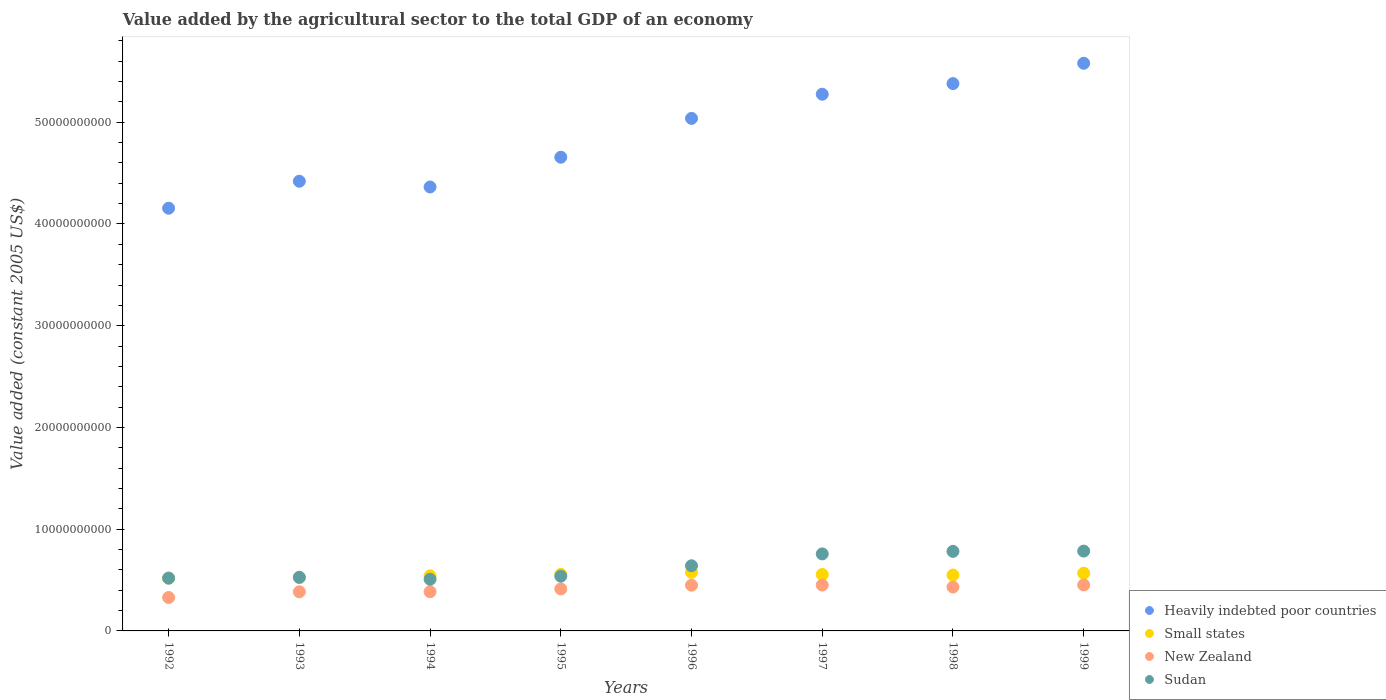Is the number of dotlines equal to the number of legend labels?
Offer a very short reply. Yes. What is the value added by the agricultural sector in Heavily indebted poor countries in 1994?
Offer a very short reply. 4.36e+1. Across all years, what is the maximum value added by the agricultural sector in New Zealand?
Your answer should be compact. 4.52e+09. Across all years, what is the minimum value added by the agricultural sector in Small states?
Offer a terse response. 5.19e+09. What is the total value added by the agricultural sector in Sudan in the graph?
Keep it short and to the point. 5.06e+1. What is the difference between the value added by the agricultural sector in Small states in 1997 and that in 1999?
Make the answer very short. -1.21e+08. What is the difference between the value added by the agricultural sector in Sudan in 1998 and the value added by the agricultural sector in New Zealand in 1992?
Provide a short and direct response. 4.54e+09. What is the average value added by the agricultural sector in Heavily indebted poor countries per year?
Give a very brief answer. 4.86e+1. In the year 1997, what is the difference between the value added by the agricultural sector in Small states and value added by the agricultural sector in Sudan?
Your answer should be very brief. -2.02e+09. What is the ratio of the value added by the agricultural sector in Small states in 1993 to that in 1995?
Your response must be concise. 0.94. Is the value added by the agricultural sector in Heavily indebted poor countries in 1996 less than that in 1998?
Make the answer very short. Yes. What is the difference between the highest and the second highest value added by the agricultural sector in New Zealand?
Your answer should be compact. 1.00e+07. What is the difference between the highest and the lowest value added by the agricultural sector in Sudan?
Make the answer very short. 2.77e+09. What is the difference between two consecutive major ticks on the Y-axis?
Make the answer very short. 1.00e+1. Does the graph contain any zero values?
Ensure brevity in your answer.  No. Where does the legend appear in the graph?
Your answer should be compact. Bottom right. How are the legend labels stacked?
Ensure brevity in your answer.  Vertical. What is the title of the graph?
Provide a succinct answer. Value added by the agricultural sector to the total GDP of an economy. What is the label or title of the X-axis?
Your answer should be very brief. Years. What is the label or title of the Y-axis?
Provide a succinct answer. Value added (constant 2005 US$). What is the Value added (constant 2005 US$) in Heavily indebted poor countries in 1992?
Provide a succinct answer. 4.15e+1. What is the Value added (constant 2005 US$) of Small states in 1992?
Your answer should be compact. 5.19e+09. What is the Value added (constant 2005 US$) in New Zealand in 1992?
Your answer should be compact. 3.28e+09. What is the Value added (constant 2005 US$) in Sudan in 1992?
Your answer should be compact. 5.19e+09. What is the Value added (constant 2005 US$) in Heavily indebted poor countries in 1993?
Give a very brief answer. 4.42e+1. What is the Value added (constant 2005 US$) of Small states in 1993?
Provide a short and direct response. 5.23e+09. What is the Value added (constant 2005 US$) of New Zealand in 1993?
Give a very brief answer. 3.84e+09. What is the Value added (constant 2005 US$) of Sudan in 1993?
Offer a terse response. 5.27e+09. What is the Value added (constant 2005 US$) of Heavily indebted poor countries in 1994?
Your response must be concise. 4.36e+1. What is the Value added (constant 2005 US$) in Small states in 1994?
Make the answer very short. 5.41e+09. What is the Value added (constant 2005 US$) in New Zealand in 1994?
Offer a terse response. 3.85e+09. What is the Value added (constant 2005 US$) in Sudan in 1994?
Offer a very short reply. 5.08e+09. What is the Value added (constant 2005 US$) in Heavily indebted poor countries in 1995?
Offer a very short reply. 4.66e+1. What is the Value added (constant 2005 US$) of Small states in 1995?
Offer a very short reply. 5.56e+09. What is the Value added (constant 2005 US$) of New Zealand in 1995?
Ensure brevity in your answer.  4.13e+09. What is the Value added (constant 2005 US$) in Sudan in 1995?
Offer a terse response. 5.38e+09. What is the Value added (constant 2005 US$) of Heavily indebted poor countries in 1996?
Offer a terse response. 5.04e+1. What is the Value added (constant 2005 US$) in Small states in 1996?
Your answer should be compact. 5.75e+09. What is the Value added (constant 2005 US$) in New Zealand in 1996?
Keep it short and to the point. 4.49e+09. What is the Value added (constant 2005 US$) in Sudan in 1996?
Your response must be concise. 6.40e+09. What is the Value added (constant 2005 US$) of Heavily indebted poor countries in 1997?
Provide a succinct answer. 5.28e+1. What is the Value added (constant 2005 US$) in Small states in 1997?
Keep it short and to the point. 5.55e+09. What is the Value added (constant 2005 US$) of New Zealand in 1997?
Provide a succinct answer. 4.51e+09. What is the Value added (constant 2005 US$) in Sudan in 1997?
Provide a succinct answer. 7.57e+09. What is the Value added (constant 2005 US$) of Heavily indebted poor countries in 1998?
Your answer should be compact. 5.38e+1. What is the Value added (constant 2005 US$) in Small states in 1998?
Your answer should be compact. 5.49e+09. What is the Value added (constant 2005 US$) in New Zealand in 1998?
Ensure brevity in your answer.  4.31e+09. What is the Value added (constant 2005 US$) in Sudan in 1998?
Your response must be concise. 7.82e+09. What is the Value added (constant 2005 US$) of Heavily indebted poor countries in 1999?
Your answer should be compact. 5.58e+1. What is the Value added (constant 2005 US$) of Small states in 1999?
Your answer should be very brief. 5.67e+09. What is the Value added (constant 2005 US$) in New Zealand in 1999?
Ensure brevity in your answer.  4.52e+09. What is the Value added (constant 2005 US$) in Sudan in 1999?
Your response must be concise. 7.85e+09. Across all years, what is the maximum Value added (constant 2005 US$) in Heavily indebted poor countries?
Provide a succinct answer. 5.58e+1. Across all years, what is the maximum Value added (constant 2005 US$) of Small states?
Ensure brevity in your answer.  5.75e+09. Across all years, what is the maximum Value added (constant 2005 US$) in New Zealand?
Your answer should be compact. 4.52e+09. Across all years, what is the maximum Value added (constant 2005 US$) in Sudan?
Offer a very short reply. 7.85e+09. Across all years, what is the minimum Value added (constant 2005 US$) in Heavily indebted poor countries?
Offer a very short reply. 4.15e+1. Across all years, what is the minimum Value added (constant 2005 US$) in Small states?
Your answer should be very brief. 5.19e+09. Across all years, what is the minimum Value added (constant 2005 US$) in New Zealand?
Your response must be concise. 3.28e+09. Across all years, what is the minimum Value added (constant 2005 US$) in Sudan?
Ensure brevity in your answer.  5.08e+09. What is the total Value added (constant 2005 US$) of Heavily indebted poor countries in the graph?
Provide a succinct answer. 3.89e+11. What is the total Value added (constant 2005 US$) in Small states in the graph?
Offer a terse response. 4.39e+1. What is the total Value added (constant 2005 US$) of New Zealand in the graph?
Provide a succinct answer. 3.29e+1. What is the total Value added (constant 2005 US$) of Sudan in the graph?
Offer a very short reply. 5.06e+1. What is the difference between the Value added (constant 2005 US$) in Heavily indebted poor countries in 1992 and that in 1993?
Offer a very short reply. -2.65e+09. What is the difference between the Value added (constant 2005 US$) in Small states in 1992 and that in 1993?
Your answer should be very brief. -3.83e+07. What is the difference between the Value added (constant 2005 US$) of New Zealand in 1992 and that in 1993?
Your response must be concise. -5.59e+08. What is the difference between the Value added (constant 2005 US$) in Sudan in 1992 and that in 1993?
Provide a succinct answer. -8.54e+07. What is the difference between the Value added (constant 2005 US$) of Heavily indebted poor countries in 1992 and that in 1994?
Provide a short and direct response. -2.09e+09. What is the difference between the Value added (constant 2005 US$) in Small states in 1992 and that in 1994?
Offer a terse response. -2.23e+08. What is the difference between the Value added (constant 2005 US$) of New Zealand in 1992 and that in 1994?
Ensure brevity in your answer.  -5.68e+08. What is the difference between the Value added (constant 2005 US$) in Sudan in 1992 and that in 1994?
Your response must be concise. 1.10e+08. What is the difference between the Value added (constant 2005 US$) of Heavily indebted poor countries in 1992 and that in 1995?
Your answer should be compact. -5.01e+09. What is the difference between the Value added (constant 2005 US$) in Small states in 1992 and that in 1995?
Your response must be concise. -3.70e+08. What is the difference between the Value added (constant 2005 US$) of New Zealand in 1992 and that in 1995?
Make the answer very short. -8.43e+08. What is the difference between the Value added (constant 2005 US$) of Sudan in 1992 and that in 1995?
Provide a short and direct response. -1.95e+08. What is the difference between the Value added (constant 2005 US$) in Heavily indebted poor countries in 1992 and that in 1996?
Offer a very short reply. -8.83e+09. What is the difference between the Value added (constant 2005 US$) in Small states in 1992 and that in 1996?
Provide a succinct answer. -5.63e+08. What is the difference between the Value added (constant 2005 US$) of New Zealand in 1992 and that in 1996?
Your response must be concise. -1.21e+09. What is the difference between the Value added (constant 2005 US$) in Sudan in 1992 and that in 1996?
Your answer should be compact. -1.22e+09. What is the difference between the Value added (constant 2005 US$) of Heavily indebted poor countries in 1992 and that in 1997?
Ensure brevity in your answer.  -1.12e+1. What is the difference between the Value added (constant 2005 US$) of Small states in 1992 and that in 1997?
Offer a very short reply. -3.58e+08. What is the difference between the Value added (constant 2005 US$) of New Zealand in 1992 and that in 1997?
Offer a very short reply. -1.22e+09. What is the difference between the Value added (constant 2005 US$) in Sudan in 1992 and that in 1997?
Give a very brief answer. -2.38e+09. What is the difference between the Value added (constant 2005 US$) of Heavily indebted poor countries in 1992 and that in 1998?
Offer a very short reply. -1.22e+1. What is the difference between the Value added (constant 2005 US$) in Small states in 1992 and that in 1998?
Ensure brevity in your answer.  -3.03e+08. What is the difference between the Value added (constant 2005 US$) in New Zealand in 1992 and that in 1998?
Offer a very short reply. -1.03e+09. What is the difference between the Value added (constant 2005 US$) of Sudan in 1992 and that in 1998?
Provide a succinct answer. -2.63e+09. What is the difference between the Value added (constant 2005 US$) of Heavily indebted poor countries in 1992 and that in 1999?
Offer a very short reply. -1.42e+1. What is the difference between the Value added (constant 2005 US$) in Small states in 1992 and that in 1999?
Provide a succinct answer. -4.79e+08. What is the difference between the Value added (constant 2005 US$) of New Zealand in 1992 and that in 1999?
Provide a succinct answer. -1.23e+09. What is the difference between the Value added (constant 2005 US$) of Sudan in 1992 and that in 1999?
Your answer should be compact. -2.66e+09. What is the difference between the Value added (constant 2005 US$) in Heavily indebted poor countries in 1993 and that in 1994?
Offer a terse response. 5.63e+08. What is the difference between the Value added (constant 2005 US$) in Small states in 1993 and that in 1994?
Ensure brevity in your answer.  -1.85e+08. What is the difference between the Value added (constant 2005 US$) of New Zealand in 1993 and that in 1994?
Ensure brevity in your answer.  -8.66e+06. What is the difference between the Value added (constant 2005 US$) of Sudan in 1993 and that in 1994?
Offer a terse response. 1.95e+08. What is the difference between the Value added (constant 2005 US$) of Heavily indebted poor countries in 1993 and that in 1995?
Your response must be concise. -2.36e+09. What is the difference between the Value added (constant 2005 US$) in Small states in 1993 and that in 1995?
Give a very brief answer. -3.31e+08. What is the difference between the Value added (constant 2005 US$) in New Zealand in 1993 and that in 1995?
Ensure brevity in your answer.  -2.84e+08. What is the difference between the Value added (constant 2005 US$) of Sudan in 1993 and that in 1995?
Provide a succinct answer. -1.09e+08. What is the difference between the Value added (constant 2005 US$) of Heavily indebted poor countries in 1993 and that in 1996?
Ensure brevity in your answer.  -6.18e+09. What is the difference between the Value added (constant 2005 US$) of Small states in 1993 and that in 1996?
Your answer should be very brief. -5.25e+08. What is the difference between the Value added (constant 2005 US$) of New Zealand in 1993 and that in 1996?
Your answer should be compact. -6.48e+08. What is the difference between the Value added (constant 2005 US$) of Sudan in 1993 and that in 1996?
Make the answer very short. -1.13e+09. What is the difference between the Value added (constant 2005 US$) of Heavily indebted poor countries in 1993 and that in 1997?
Offer a very short reply. -8.55e+09. What is the difference between the Value added (constant 2005 US$) of Small states in 1993 and that in 1997?
Your answer should be compact. -3.19e+08. What is the difference between the Value added (constant 2005 US$) in New Zealand in 1993 and that in 1997?
Keep it short and to the point. -6.66e+08. What is the difference between the Value added (constant 2005 US$) in Sudan in 1993 and that in 1997?
Your answer should be very brief. -2.30e+09. What is the difference between the Value added (constant 2005 US$) in Heavily indebted poor countries in 1993 and that in 1998?
Give a very brief answer. -9.60e+09. What is the difference between the Value added (constant 2005 US$) in Small states in 1993 and that in 1998?
Offer a very short reply. -2.65e+08. What is the difference between the Value added (constant 2005 US$) of New Zealand in 1993 and that in 1998?
Offer a very short reply. -4.70e+08. What is the difference between the Value added (constant 2005 US$) in Sudan in 1993 and that in 1998?
Your answer should be very brief. -2.55e+09. What is the difference between the Value added (constant 2005 US$) of Heavily indebted poor countries in 1993 and that in 1999?
Keep it short and to the point. -1.16e+1. What is the difference between the Value added (constant 2005 US$) of Small states in 1993 and that in 1999?
Provide a short and direct response. -4.41e+08. What is the difference between the Value added (constant 2005 US$) of New Zealand in 1993 and that in 1999?
Keep it short and to the point. -6.76e+08. What is the difference between the Value added (constant 2005 US$) in Sudan in 1993 and that in 1999?
Offer a terse response. -2.57e+09. What is the difference between the Value added (constant 2005 US$) in Heavily indebted poor countries in 1994 and that in 1995?
Provide a short and direct response. -2.92e+09. What is the difference between the Value added (constant 2005 US$) in Small states in 1994 and that in 1995?
Keep it short and to the point. -1.46e+08. What is the difference between the Value added (constant 2005 US$) of New Zealand in 1994 and that in 1995?
Your answer should be very brief. -2.75e+08. What is the difference between the Value added (constant 2005 US$) of Sudan in 1994 and that in 1995?
Give a very brief answer. -3.05e+08. What is the difference between the Value added (constant 2005 US$) of Heavily indebted poor countries in 1994 and that in 1996?
Offer a terse response. -6.74e+09. What is the difference between the Value added (constant 2005 US$) of Small states in 1994 and that in 1996?
Offer a very short reply. -3.40e+08. What is the difference between the Value added (constant 2005 US$) in New Zealand in 1994 and that in 1996?
Your answer should be very brief. -6.40e+08. What is the difference between the Value added (constant 2005 US$) in Sudan in 1994 and that in 1996?
Provide a succinct answer. -1.33e+09. What is the difference between the Value added (constant 2005 US$) in Heavily indebted poor countries in 1994 and that in 1997?
Offer a terse response. -9.12e+09. What is the difference between the Value added (constant 2005 US$) of Small states in 1994 and that in 1997?
Ensure brevity in your answer.  -1.34e+08. What is the difference between the Value added (constant 2005 US$) of New Zealand in 1994 and that in 1997?
Your response must be concise. -6.57e+08. What is the difference between the Value added (constant 2005 US$) in Sudan in 1994 and that in 1997?
Provide a short and direct response. -2.49e+09. What is the difference between the Value added (constant 2005 US$) of Heavily indebted poor countries in 1994 and that in 1998?
Your response must be concise. -1.02e+1. What is the difference between the Value added (constant 2005 US$) of Small states in 1994 and that in 1998?
Offer a terse response. -8.01e+07. What is the difference between the Value added (constant 2005 US$) in New Zealand in 1994 and that in 1998?
Your answer should be very brief. -4.61e+08. What is the difference between the Value added (constant 2005 US$) of Sudan in 1994 and that in 1998?
Your answer should be compact. -2.74e+09. What is the difference between the Value added (constant 2005 US$) of Heavily indebted poor countries in 1994 and that in 1999?
Give a very brief answer. -1.22e+1. What is the difference between the Value added (constant 2005 US$) in Small states in 1994 and that in 1999?
Your answer should be very brief. -2.56e+08. What is the difference between the Value added (constant 2005 US$) in New Zealand in 1994 and that in 1999?
Offer a very short reply. -6.67e+08. What is the difference between the Value added (constant 2005 US$) of Sudan in 1994 and that in 1999?
Offer a very short reply. -2.77e+09. What is the difference between the Value added (constant 2005 US$) in Heavily indebted poor countries in 1995 and that in 1996?
Offer a very short reply. -3.82e+09. What is the difference between the Value added (constant 2005 US$) of Small states in 1995 and that in 1996?
Give a very brief answer. -1.94e+08. What is the difference between the Value added (constant 2005 US$) of New Zealand in 1995 and that in 1996?
Give a very brief answer. -3.64e+08. What is the difference between the Value added (constant 2005 US$) of Sudan in 1995 and that in 1996?
Offer a terse response. -1.02e+09. What is the difference between the Value added (constant 2005 US$) in Heavily indebted poor countries in 1995 and that in 1997?
Ensure brevity in your answer.  -6.19e+09. What is the difference between the Value added (constant 2005 US$) in Small states in 1995 and that in 1997?
Keep it short and to the point. 1.20e+07. What is the difference between the Value added (constant 2005 US$) of New Zealand in 1995 and that in 1997?
Ensure brevity in your answer.  -3.82e+08. What is the difference between the Value added (constant 2005 US$) of Sudan in 1995 and that in 1997?
Your answer should be very brief. -2.19e+09. What is the difference between the Value added (constant 2005 US$) of Heavily indebted poor countries in 1995 and that in 1998?
Provide a succinct answer. -7.24e+09. What is the difference between the Value added (constant 2005 US$) in Small states in 1995 and that in 1998?
Make the answer very short. 6.63e+07. What is the difference between the Value added (constant 2005 US$) in New Zealand in 1995 and that in 1998?
Provide a short and direct response. -1.86e+08. What is the difference between the Value added (constant 2005 US$) in Sudan in 1995 and that in 1998?
Give a very brief answer. -2.44e+09. What is the difference between the Value added (constant 2005 US$) in Heavily indebted poor countries in 1995 and that in 1999?
Your answer should be compact. -9.23e+09. What is the difference between the Value added (constant 2005 US$) of Small states in 1995 and that in 1999?
Give a very brief answer. -1.09e+08. What is the difference between the Value added (constant 2005 US$) in New Zealand in 1995 and that in 1999?
Your response must be concise. -3.92e+08. What is the difference between the Value added (constant 2005 US$) in Sudan in 1995 and that in 1999?
Provide a succinct answer. -2.46e+09. What is the difference between the Value added (constant 2005 US$) of Heavily indebted poor countries in 1996 and that in 1997?
Provide a succinct answer. -2.37e+09. What is the difference between the Value added (constant 2005 US$) of Small states in 1996 and that in 1997?
Your answer should be very brief. 2.05e+08. What is the difference between the Value added (constant 2005 US$) in New Zealand in 1996 and that in 1997?
Provide a short and direct response. -1.73e+07. What is the difference between the Value added (constant 2005 US$) in Sudan in 1996 and that in 1997?
Ensure brevity in your answer.  -1.17e+09. What is the difference between the Value added (constant 2005 US$) in Heavily indebted poor countries in 1996 and that in 1998?
Provide a short and direct response. -3.42e+09. What is the difference between the Value added (constant 2005 US$) of Small states in 1996 and that in 1998?
Provide a short and direct response. 2.60e+08. What is the difference between the Value added (constant 2005 US$) of New Zealand in 1996 and that in 1998?
Offer a terse response. 1.79e+08. What is the difference between the Value added (constant 2005 US$) of Sudan in 1996 and that in 1998?
Offer a very short reply. -1.42e+09. What is the difference between the Value added (constant 2005 US$) in Heavily indebted poor countries in 1996 and that in 1999?
Your answer should be very brief. -5.42e+09. What is the difference between the Value added (constant 2005 US$) in Small states in 1996 and that in 1999?
Your answer should be compact. 8.41e+07. What is the difference between the Value added (constant 2005 US$) of New Zealand in 1996 and that in 1999?
Keep it short and to the point. -2.74e+07. What is the difference between the Value added (constant 2005 US$) in Sudan in 1996 and that in 1999?
Provide a short and direct response. -1.44e+09. What is the difference between the Value added (constant 2005 US$) of Heavily indebted poor countries in 1997 and that in 1998?
Offer a terse response. -1.04e+09. What is the difference between the Value added (constant 2005 US$) of Small states in 1997 and that in 1998?
Keep it short and to the point. 5.43e+07. What is the difference between the Value added (constant 2005 US$) of New Zealand in 1997 and that in 1998?
Your answer should be compact. 1.96e+08. What is the difference between the Value added (constant 2005 US$) of Sudan in 1997 and that in 1998?
Give a very brief answer. -2.50e+08. What is the difference between the Value added (constant 2005 US$) of Heavily indebted poor countries in 1997 and that in 1999?
Ensure brevity in your answer.  -3.04e+09. What is the difference between the Value added (constant 2005 US$) in Small states in 1997 and that in 1999?
Your answer should be compact. -1.21e+08. What is the difference between the Value added (constant 2005 US$) in New Zealand in 1997 and that in 1999?
Ensure brevity in your answer.  -1.00e+07. What is the difference between the Value added (constant 2005 US$) in Sudan in 1997 and that in 1999?
Ensure brevity in your answer.  -2.76e+08. What is the difference between the Value added (constant 2005 US$) in Heavily indebted poor countries in 1998 and that in 1999?
Your answer should be very brief. -2.00e+09. What is the difference between the Value added (constant 2005 US$) in Small states in 1998 and that in 1999?
Provide a succinct answer. -1.76e+08. What is the difference between the Value added (constant 2005 US$) of New Zealand in 1998 and that in 1999?
Your answer should be compact. -2.06e+08. What is the difference between the Value added (constant 2005 US$) in Sudan in 1998 and that in 1999?
Your response must be concise. -2.61e+07. What is the difference between the Value added (constant 2005 US$) of Heavily indebted poor countries in 1992 and the Value added (constant 2005 US$) of Small states in 1993?
Give a very brief answer. 3.63e+1. What is the difference between the Value added (constant 2005 US$) of Heavily indebted poor countries in 1992 and the Value added (constant 2005 US$) of New Zealand in 1993?
Your answer should be compact. 3.77e+1. What is the difference between the Value added (constant 2005 US$) of Heavily indebted poor countries in 1992 and the Value added (constant 2005 US$) of Sudan in 1993?
Provide a short and direct response. 3.63e+1. What is the difference between the Value added (constant 2005 US$) in Small states in 1992 and the Value added (constant 2005 US$) in New Zealand in 1993?
Your answer should be compact. 1.35e+09. What is the difference between the Value added (constant 2005 US$) of Small states in 1992 and the Value added (constant 2005 US$) of Sudan in 1993?
Offer a terse response. -8.18e+07. What is the difference between the Value added (constant 2005 US$) of New Zealand in 1992 and the Value added (constant 2005 US$) of Sudan in 1993?
Keep it short and to the point. -1.99e+09. What is the difference between the Value added (constant 2005 US$) of Heavily indebted poor countries in 1992 and the Value added (constant 2005 US$) of Small states in 1994?
Your answer should be compact. 3.61e+1. What is the difference between the Value added (constant 2005 US$) in Heavily indebted poor countries in 1992 and the Value added (constant 2005 US$) in New Zealand in 1994?
Your response must be concise. 3.77e+1. What is the difference between the Value added (constant 2005 US$) of Heavily indebted poor countries in 1992 and the Value added (constant 2005 US$) of Sudan in 1994?
Provide a short and direct response. 3.65e+1. What is the difference between the Value added (constant 2005 US$) in Small states in 1992 and the Value added (constant 2005 US$) in New Zealand in 1994?
Your answer should be very brief. 1.34e+09. What is the difference between the Value added (constant 2005 US$) in Small states in 1992 and the Value added (constant 2005 US$) in Sudan in 1994?
Provide a succinct answer. 1.14e+08. What is the difference between the Value added (constant 2005 US$) of New Zealand in 1992 and the Value added (constant 2005 US$) of Sudan in 1994?
Keep it short and to the point. -1.79e+09. What is the difference between the Value added (constant 2005 US$) in Heavily indebted poor countries in 1992 and the Value added (constant 2005 US$) in Small states in 1995?
Your answer should be compact. 3.60e+1. What is the difference between the Value added (constant 2005 US$) of Heavily indebted poor countries in 1992 and the Value added (constant 2005 US$) of New Zealand in 1995?
Provide a succinct answer. 3.74e+1. What is the difference between the Value added (constant 2005 US$) of Heavily indebted poor countries in 1992 and the Value added (constant 2005 US$) of Sudan in 1995?
Ensure brevity in your answer.  3.62e+1. What is the difference between the Value added (constant 2005 US$) of Small states in 1992 and the Value added (constant 2005 US$) of New Zealand in 1995?
Make the answer very short. 1.06e+09. What is the difference between the Value added (constant 2005 US$) in Small states in 1992 and the Value added (constant 2005 US$) in Sudan in 1995?
Provide a succinct answer. -1.91e+08. What is the difference between the Value added (constant 2005 US$) of New Zealand in 1992 and the Value added (constant 2005 US$) of Sudan in 1995?
Your response must be concise. -2.10e+09. What is the difference between the Value added (constant 2005 US$) in Heavily indebted poor countries in 1992 and the Value added (constant 2005 US$) in Small states in 1996?
Make the answer very short. 3.58e+1. What is the difference between the Value added (constant 2005 US$) in Heavily indebted poor countries in 1992 and the Value added (constant 2005 US$) in New Zealand in 1996?
Ensure brevity in your answer.  3.71e+1. What is the difference between the Value added (constant 2005 US$) in Heavily indebted poor countries in 1992 and the Value added (constant 2005 US$) in Sudan in 1996?
Ensure brevity in your answer.  3.51e+1. What is the difference between the Value added (constant 2005 US$) of Small states in 1992 and the Value added (constant 2005 US$) of New Zealand in 1996?
Provide a succinct answer. 6.98e+08. What is the difference between the Value added (constant 2005 US$) of Small states in 1992 and the Value added (constant 2005 US$) of Sudan in 1996?
Offer a terse response. -1.21e+09. What is the difference between the Value added (constant 2005 US$) of New Zealand in 1992 and the Value added (constant 2005 US$) of Sudan in 1996?
Keep it short and to the point. -3.12e+09. What is the difference between the Value added (constant 2005 US$) of Heavily indebted poor countries in 1992 and the Value added (constant 2005 US$) of Small states in 1997?
Keep it short and to the point. 3.60e+1. What is the difference between the Value added (constant 2005 US$) of Heavily indebted poor countries in 1992 and the Value added (constant 2005 US$) of New Zealand in 1997?
Offer a very short reply. 3.70e+1. What is the difference between the Value added (constant 2005 US$) in Heavily indebted poor countries in 1992 and the Value added (constant 2005 US$) in Sudan in 1997?
Your answer should be compact. 3.40e+1. What is the difference between the Value added (constant 2005 US$) of Small states in 1992 and the Value added (constant 2005 US$) of New Zealand in 1997?
Your response must be concise. 6.81e+08. What is the difference between the Value added (constant 2005 US$) in Small states in 1992 and the Value added (constant 2005 US$) in Sudan in 1997?
Your response must be concise. -2.38e+09. What is the difference between the Value added (constant 2005 US$) in New Zealand in 1992 and the Value added (constant 2005 US$) in Sudan in 1997?
Provide a succinct answer. -4.29e+09. What is the difference between the Value added (constant 2005 US$) of Heavily indebted poor countries in 1992 and the Value added (constant 2005 US$) of Small states in 1998?
Provide a short and direct response. 3.61e+1. What is the difference between the Value added (constant 2005 US$) in Heavily indebted poor countries in 1992 and the Value added (constant 2005 US$) in New Zealand in 1998?
Keep it short and to the point. 3.72e+1. What is the difference between the Value added (constant 2005 US$) of Heavily indebted poor countries in 1992 and the Value added (constant 2005 US$) of Sudan in 1998?
Provide a succinct answer. 3.37e+1. What is the difference between the Value added (constant 2005 US$) of Small states in 1992 and the Value added (constant 2005 US$) of New Zealand in 1998?
Your response must be concise. 8.77e+08. What is the difference between the Value added (constant 2005 US$) in Small states in 1992 and the Value added (constant 2005 US$) in Sudan in 1998?
Offer a very short reply. -2.63e+09. What is the difference between the Value added (constant 2005 US$) of New Zealand in 1992 and the Value added (constant 2005 US$) of Sudan in 1998?
Provide a succinct answer. -4.54e+09. What is the difference between the Value added (constant 2005 US$) in Heavily indebted poor countries in 1992 and the Value added (constant 2005 US$) in Small states in 1999?
Offer a very short reply. 3.59e+1. What is the difference between the Value added (constant 2005 US$) in Heavily indebted poor countries in 1992 and the Value added (constant 2005 US$) in New Zealand in 1999?
Your answer should be very brief. 3.70e+1. What is the difference between the Value added (constant 2005 US$) in Heavily indebted poor countries in 1992 and the Value added (constant 2005 US$) in Sudan in 1999?
Offer a terse response. 3.37e+1. What is the difference between the Value added (constant 2005 US$) in Small states in 1992 and the Value added (constant 2005 US$) in New Zealand in 1999?
Make the answer very short. 6.71e+08. What is the difference between the Value added (constant 2005 US$) in Small states in 1992 and the Value added (constant 2005 US$) in Sudan in 1999?
Make the answer very short. -2.66e+09. What is the difference between the Value added (constant 2005 US$) of New Zealand in 1992 and the Value added (constant 2005 US$) of Sudan in 1999?
Make the answer very short. -4.56e+09. What is the difference between the Value added (constant 2005 US$) in Heavily indebted poor countries in 1993 and the Value added (constant 2005 US$) in Small states in 1994?
Your answer should be compact. 3.88e+1. What is the difference between the Value added (constant 2005 US$) in Heavily indebted poor countries in 1993 and the Value added (constant 2005 US$) in New Zealand in 1994?
Keep it short and to the point. 4.03e+1. What is the difference between the Value added (constant 2005 US$) of Heavily indebted poor countries in 1993 and the Value added (constant 2005 US$) of Sudan in 1994?
Offer a very short reply. 3.91e+1. What is the difference between the Value added (constant 2005 US$) in Small states in 1993 and the Value added (constant 2005 US$) in New Zealand in 1994?
Provide a succinct answer. 1.38e+09. What is the difference between the Value added (constant 2005 US$) in Small states in 1993 and the Value added (constant 2005 US$) in Sudan in 1994?
Your answer should be compact. 1.52e+08. What is the difference between the Value added (constant 2005 US$) of New Zealand in 1993 and the Value added (constant 2005 US$) of Sudan in 1994?
Keep it short and to the point. -1.23e+09. What is the difference between the Value added (constant 2005 US$) of Heavily indebted poor countries in 1993 and the Value added (constant 2005 US$) of Small states in 1995?
Make the answer very short. 3.86e+1. What is the difference between the Value added (constant 2005 US$) of Heavily indebted poor countries in 1993 and the Value added (constant 2005 US$) of New Zealand in 1995?
Your answer should be very brief. 4.01e+1. What is the difference between the Value added (constant 2005 US$) in Heavily indebted poor countries in 1993 and the Value added (constant 2005 US$) in Sudan in 1995?
Your answer should be compact. 3.88e+1. What is the difference between the Value added (constant 2005 US$) of Small states in 1993 and the Value added (constant 2005 US$) of New Zealand in 1995?
Keep it short and to the point. 1.10e+09. What is the difference between the Value added (constant 2005 US$) of Small states in 1993 and the Value added (constant 2005 US$) of Sudan in 1995?
Make the answer very short. -1.53e+08. What is the difference between the Value added (constant 2005 US$) of New Zealand in 1993 and the Value added (constant 2005 US$) of Sudan in 1995?
Keep it short and to the point. -1.54e+09. What is the difference between the Value added (constant 2005 US$) in Heavily indebted poor countries in 1993 and the Value added (constant 2005 US$) in Small states in 1996?
Provide a short and direct response. 3.84e+1. What is the difference between the Value added (constant 2005 US$) of Heavily indebted poor countries in 1993 and the Value added (constant 2005 US$) of New Zealand in 1996?
Your answer should be very brief. 3.97e+1. What is the difference between the Value added (constant 2005 US$) of Heavily indebted poor countries in 1993 and the Value added (constant 2005 US$) of Sudan in 1996?
Your answer should be very brief. 3.78e+1. What is the difference between the Value added (constant 2005 US$) of Small states in 1993 and the Value added (constant 2005 US$) of New Zealand in 1996?
Offer a very short reply. 7.37e+08. What is the difference between the Value added (constant 2005 US$) in Small states in 1993 and the Value added (constant 2005 US$) in Sudan in 1996?
Offer a very short reply. -1.17e+09. What is the difference between the Value added (constant 2005 US$) of New Zealand in 1993 and the Value added (constant 2005 US$) of Sudan in 1996?
Offer a very short reply. -2.56e+09. What is the difference between the Value added (constant 2005 US$) of Heavily indebted poor countries in 1993 and the Value added (constant 2005 US$) of Small states in 1997?
Provide a short and direct response. 3.87e+1. What is the difference between the Value added (constant 2005 US$) of Heavily indebted poor countries in 1993 and the Value added (constant 2005 US$) of New Zealand in 1997?
Keep it short and to the point. 3.97e+1. What is the difference between the Value added (constant 2005 US$) of Heavily indebted poor countries in 1993 and the Value added (constant 2005 US$) of Sudan in 1997?
Ensure brevity in your answer.  3.66e+1. What is the difference between the Value added (constant 2005 US$) of Small states in 1993 and the Value added (constant 2005 US$) of New Zealand in 1997?
Give a very brief answer. 7.19e+08. What is the difference between the Value added (constant 2005 US$) of Small states in 1993 and the Value added (constant 2005 US$) of Sudan in 1997?
Your response must be concise. -2.34e+09. What is the difference between the Value added (constant 2005 US$) of New Zealand in 1993 and the Value added (constant 2005 US$) of Sudan in 1997?
Offer a terse response. -3.73e+09. What is the difference between the Value added (constant 2005 US$) of Heavily indebted poor countries in 1993 and the Value added (constant 2005 US$) of Small states in 1998?
Make the answer very short. 3.87e+1. What is the difference between the Value added (constant 2005 US$) of Heavily indebted poor countries in 1993 and the Value added (constant 2005 US$) of New Zealand in 1998?
Offer a very short reply. 3.99e+1. What is the difference between the Value added (constant 2005 US$) in Heavily indebted poor countries in 1993 and the Value added (constant 2005 US$) in Sudan in 1998?
Keep it short and to the point. 3.64e+1. What is the difference between the Value added (constant 2005 US$) in Small states in 1993 and the Value added (constant 2005 US$) in New Zealand in 1998?
Make the answer very short. 9.16e+08. What is the difference between the Value added (constant 2005 US$) of Small states in 1993 and the Value added (constant 2005 US$) of Sudan in 1998?
Give a very brief answer. -2.59e+09. What is the difference between the Value added (constant 2005 US$) in New Zealand in 1993 and the Value added (constant 2005 US$) in Sudan in 1998?
Your answer should be compact. -3.98e+09. What is the difference between the Value added (constant 2005 US$) of Heavily indebted poor countries in 1993 and the Value added (constant 2005 US$) of Small states in 1999?
Ensure brevity in your answer.  3.85e+1. What is the difference between the Value added (constant 2005 US$) of Heavily indebted poor countries in 1993 and the Value added (constant 2005 US$) of New Zealand in 1999?
Your answer should be compact. 3.97e+1. What is the difference between the Value added (constant 2005 US$) in Heavily indebted poor countries in 1993 and the Value added (constant 2005 US$) in Sudan in 1999?
Ensure brevity in your answer.  3.64e+1. What is the difference between the Value added (constant 2005 US$) in Small states in 1993 and the Value added (constant 2005 US$) in New Zealand in 1999?
Ensure brevity in your answer.  7.09e+08. What is the difference between the Value added (constant 2005 US$) in Small states in 1993 and the Value added (constant 2005 US$) in Sudan in 1999?
Give a very brief answer. -2.62e+09. What is the difference between the Value added (constant 2005 US$) of New Zealand in 1993 and the Value added (constant 2005 US$) of Sudan in 1999?
Ensure brevity in your answer.  -4.00e+09. What is the difference between the Value added (constant 2005 US$) in Heavily indebted poor countries in 1994 and the Value added (constant 2005 US$) in Small states in 1995?
Make the answer very short. 3.81e+1. What is the difference between the Value added (constant 2005 US$) in Heavily indebted poor countries in 1994 and the Value added (constant 2005 US$) in New Zealand in 1995?
Offer a terse response. 3.95e+1. What is the difference between the Value added (constant 2005 US$) in Heavily indebted poor countries in 1994 and the Value added (constant 2005 US$) in Sudan in 1995?
Make the answer very short. 3.83e+1. What is the difference between the Value added (constant 2005 US$) of Small states in 1994 and the Value added (constant 2005 US$) of New Zealand in 1995?
Offer a very short reply. 1.29e+09. What is the difference between the Value added (constant 2005 US$) in Small states in 1994 and the Value added (constant 2005 US$) in Sudan in 1995?
Offer a very short reply. 3.20e+07. What is the difference between the Value added (constant 2005 US$) in New Zealand in 1994 and the Value added (constant 2005 US$) in Sudan in 1995?
Make the answer very short. -1.53e+09. What is the difference between the Value added (constant 2005 US$) of Heavily indebted poor countries in 1994 and the Value added (constant 2005 US$) of Small states in 1996?
Your answer should be very brief. 3.79e+1. What is the difference between the Value added (constant 2005 US$) in Heavily indebted poor countries in 1994 and the Value added (constant 2005 US$) in New Zealand in 1996?
Provide a short and direct response. 3.91e+1. What is the difference between the Value added (constant 2005 US$) in Heavily indebted poor countries in 1994 and the Value added (constant 2005 US$) in Sudan in 1996?
Provide a succinct answer. 3.72e+1. What is the difference between the Value added (constant 2005 US$) in Small states in 1994 and the Value added (constant 2005 US$) in New Zealand in 1996?
Your answer should be very brief. 9.22e+08. What is the difference between the Value added (constant 2005 US$) of Small states in 1994 and the Value added (constant 2005 US$) of Sudan in 1996?
Offer a terse response. -9.89e+08. What is the difference between the Value added (constant 2005 US$) in New Zealand in 1994 and the Value added (constant 2005 US$) in Sudan in 1996?
Offer a very short reply. -2.55e+09. What is the difference between the Value added (constant 2005 US$) in Heavily indebted poor countries in 1994 and the Value added (constant 2005 US$) in Small states in 1997?
Offer a very short reply. 3.81e+1. What is the difference between the Value added (constant 2005 US$) of Heavily indebted poor countries in 1994 and the Value added (constant 2005 US$) of New Zealand in 1997?
Ensure brevity in your answer.  3.91e+1. What is the difference between the Value added (constant 2005 US$) of Heavily indebted poor countries in 1994 and the Value added (constant 2005 US$) of Sudan in 1997?
Provide a succinct answer. 3.61e+1. What is the difference between the Value added (constant 2005 US$) in Small states in 1994 and the Value added (constant 2005 US$) in New Zealand in 1997?
Give a very brief answer. 9.04e+08. What is the difference between the Value added (constant 2005 US$) in Small states in 1994 and the Value added (constant 2005 US$) in Sudan in 1997?
Ensure brevity in your answer.  -2.16e+09. What is the difference between the Value added (constant 2005 US$) in New Zealand in 1994 and the Value added (constant 2005 US$) in Sudan in 1997?
Your answer should be compact. -3.72e+09. What is the difference between the Value added (constant 2005 US$) in Heavily indebted poor countries in 1994 and the Value added (constant 2005 US$) in Small states in 1998?
Your answer should be compact. 3.81e+1. What is the difference between the Value added (constant 2005 US$) in Heavily indebted poor countries in 1994 and the Value added (constant 2005 US$) in New Zealand in 1998?
Offer a very short reply. 3.93e+1. What is the difference between the Value added (constant 2005 US$) in Heavily indebted poor countries in 1994 and the Value added (constant 2005 US$) in Sudan in 1998?
Your answer should be very brief. 3.58e+1. What is the difference between the Value added (constant 2005 US$) in Small states in 1994 and the Value added (constant 2005 US$) in New Zealand in 1998?
Your answer should be very brief. 1.10e+09. What is the difference between the Value added (constant 2005 US$) in Small states in 1994 and the Value added (constant 2005 US$) in Sudan in 1998?
Your response must be concise. -2.41e+09. What is the difference between the Value added (constant 2005 US$) of New Zealand in 1994 and the Value added (constant 2005 US$) of Sudan in 1998?
Give a very brief answer. -3.97e+09. What is the difference between the Value added (constant 2005 US$) in Heavily indebted poor countries in 1994 and the Value added (constant 2005 US$) in Small states in 1999?
Provide a short and direct response. 3.80e+1. What is the difference between the Value added (constant 2005 US$) of Heavily indebted poor countries in 1994 and the Value added (constant 2005 US$) of New Zealand in 1999?
Provide a short and direct response. 3.91e+1. What is the difference between the Value added (constant 2005 US$) of Heavily indebted poor countries in 1994 and the Value added (constant 2005 US$) of Sudan in 1999?
Your response must be concise. 3.58e+1. What is the difference between the Value added (constant 2005 US$) of Small states in 1994 and the Value added (constant 2005 US$) of New Zealand in 1999?
Provide a short and direct response. 8.94e+08. What is the difference between the Value added (constant 2005 US$) in Small states in 1994 and the Value added (constant 2005 US$) in Sudan in 1999?
Give a very brief answer. -2.43e+09. What is the difference between the Value added (constant 2005 US$) of New Zealand in 1994 and the Value added (constant 2005 US$) of Sudan in 1999?
Offer a terse response. -3.99e+09. What is the difference between the Value added (constant 2005 US$) in Heavily indebted poor countries in 1995 and the Value added (constant 2005 US$) in Small states in 1996?
Offer a terse response. 4.08e+1. What is the difference between the Value added (constant 2005 US$) in Heavily indebted poor countries in 1995 and the Value added (constant 2005 US$) in New Zealand in 1996?
Your answer should be very brief. 4.21e+1. What is the difference between the Value added (constant 2005 US$) in Heavily indebted poor countries in 1995 and the Value added (constant 2005 US$) in Sudan in 1996?
Keep it short and to the point. 4.02e+1. What is the difference between the Value added (constant 2005 US$) in Small states in 1995 and the Value added (constant 2005 US$) in New Zealand in 1996?
Offer a very short reply. 1.07e+09. What is the difference between the Value added (constant 2005 US$) of Small states in 1995 and the Value added (constant 2005 US$) of Sudan in 1996?
Give a very brief answer. -8.42e+08. What is the difference between the Value added (constant 2005 US$) of New Zealand in 1995 and the Value added (constant 2005 US$) of Sudan in 1996?
Your response must be concise. -2.27e+09. What is the difference between the Value added (constant 2005 US$) of Heavily indebted poor countries in 1995 and the Value added (constant 2005 US$) of Small states in 1997?
Your answer should be very brief. 4.10e+1. What is the difference between the Value added (constant 2005 US$) of Heavily indebted poor countries in 1995 and the Value added (constant 2005 US$) of New Zealand in 1997?
Keep it short and to the point. 4.21e+1. What is the difference between the Value added (constant 2005 US$) in Heavily indebted poor countries in 1995 and the Value added (constant 2005 US$) in Sudan in 1997?
Make the answer very short. 3.90e+1. What is the difference between the Value added (constant 2005 US$) of Small states in 1995 and the Value added (constant 2005 US$) of New Zealand in 1997?
Give a very brief answer. 1.05e+09. What is the difference between the Value added (constant 2005 US$) in Small states in 1995 and the Value added (constant 2005 US$) in Sudan in 1997?
Provide a succinct answer. -2.01e+09. What is the difference between the Value added (constant 2005 US$) in New Zealand in 1995 and the Value added (constant 2005 US$) in Sudan in 1997?
Give a very brief answer. -3.44e+09. What is the difference between the Value added (constant 2005 US$) in Heavily indebted poor countries in 1995 and the Value added (constant 2005 US$) in Small states in 1998?
Your response must be concise. 4.11e+1. What is the difference between the Value added (constant 2005 US$) in Heavily indebted poor countries in 1995 and the Value added (constant 2005 US$) in New Zealand in 1998?
Provide a short and direct response. 4.22e+1. What is the difference between the Value added (constant 2005 US$) of Heavily indebted poor countries in 1995 and the Value added (constant 2005 US$) of Sudan in 1998?
Offer a terse response. 3.87e+1. What is the difference between the Value added (constant 2005 US$) in Small states in 1995 and the Value added (constant 2005 US$) in New Zealand in 1998?
Keep it short and to the point. 1.25e+09. What is the difference between the Value added (constant 2005 US$) of Small states in 1995 and the Value added (constant 2005 US$) of Sudan in 1998?
Ensure brevity in your answer.  -2.26e+09. What is the difference between the Value added (constant 2005 US$) of New Zealand in 1995 and the Value added (constant 2005 US$) of Sudan in 1998?
Keep it short and to the point. -3.69e+09. What is the difference between the Value added (constant 2005 US$) in Heavily indebted poor countries in 1995 and the Value added (constant 2005 US$) in Small states in 1999?
Give a very brief answer. 4.09e+1. What is the difference between the Value added (constant 2005 US$) of Heavily indebted poor countries in 1995 and the Value added (constant 2005 US$) of New Zealand in 1999?
Offer a very short reply. 4.20e+1. What is the difference between the Value added (constant 2005 US$) of Heavily indebted poor countries in 1995 and the Value added (constant 2005 US$) of Sudan in 1999?
Your answer should be compact. 3.87e+1. What is the difference between the Value added (constant 2005 US$) of Small states in 1995 and the Value added (constant 2005 US$) of New Zealand in 1999?
Keep it short and to the point. 1.04e+09. What is the difference between the Value added (constant 2005 US$) of Small states in 1995 and the Value added (constant 2005 US$) of Sudan in 1999?
Ensure brevity in your answer.  -2.29e+09. What is the difference between the Value added (constant 2005 US$) in New Zealand in 1995 and the Value added (constant 2005 US$) in Sudan in 1999?
Ensure brevity in your answer.  -3.72e+09. What is the difference between the Value added (constant 2005 US$) in Heavily indebted poor countries in 1996 and the Value added (constant 2005 US$) in Small states in 1997?
Give a very brief answer. 4.48e+1. What is the difference between the Value added (constant 2005 US$) of Heavily indebted poor countries in 1996 and the Value added (constant 2005 US$) of New Zealand in 1997?
Offer a terse response. 4.59e+1. What is the difference between the Value added (constant 2005 US$) of Heavily indebted poor countries in 1996 and the Value added (constant 2005 US$) of Sudan in 1997?
Provide a succinct answer. 4.28e+1. What is the difference between the Value added (constant 2005 US$) in Small states in 1996 and the Value added (constant 2005 US$) in New Zealand in 1997?
Your response must be concise. 1.24e+09. What is the difference between the Value added (constant 2005 US$) of Small states in 1996 and the Value added (constant 2005 US$) of Sudan in 1997?
Keep it short and to the point. -1.82e+09. What is the difference between the Value added (constant 2005 US$) of New Zealand in 1996 and the Value added (constant 2005 US$) of Sudan in 1997?
Provide a succinct answer. -3.08e+09. What is the difference between the Value added (constant 2005 US$) of Heavily indebted poor countries in 1996 and the Value added (constant 2005 US$) of Small states in 1998?
Give a very brief answer. 4.49e+1. What is the difference between the Value added (constant 2005 US$) of Heavily indebted poor countries in 1996 and the Value added (constant 2005 US$) of New Zealand in 1998?
Your answer should be very brief. 4.61e+1. What is the difference between the Value added (constant 2005 US$) of Heavily indebted poor countries in 1996 and the Value added (constant 2005 US$) of Sudan in 1998?
Provide a succinct answer. 4.26e+1. What is the difference between the Value added (constant 2005 US$) of Small states in 1996 and the Value added (constant 2005 US$) of New Zealand in 1998?
Provide a succinct answer. 1.44e+09. What is the difference between the Value added (constant 2005 US$) of Small states in 1996 and the Value added (constant 2005 US$) of Sudan in 1998?
Your answer should be very brief. -2.07e+09. What is the difference between the Value added (constant 2005 US$) in New Zealand in 1996 and the Value added (constant 2005 US$) in Sudan in 1998?
Make the answer very short. -3.33e+09. What is the difference between the Value added (constant 2005 US$) in Heavily indebted poor countries in 1996 and the Value added (constant 2005 US$) in Small states in 1999?
Your response must be concise. 4.47e+1. What is the difference between the Value added (constant 2005 US$) in Heavily indebted poor countries in 1996 and the Value added (constant 2005 US$) in New Zealand in 1999?
Offer a very short reply. 4.59e+1. What is the difference between the Value added (constant 2005 US$) in Heavily indebted poor countries in 1996 and the Value added (constant 2005 US$) in Sudan in 1999?
Your response must be concise. 4.25e+1. What is the difference between the Value added (constant 2005 US$) in Small states in 1996 and the Value added (constant 2005 US$) in New Zealand in 1999?
Your answer should be compact. 1.23e+09. What is the difference between the Value added (constant 2005 US$) in Small states in 1996 and the Value added (constant 2005 US$) in Sudan in 1999?
Make the answer very short. -2.09e+09. What is the difference between the Value added (constant 2005 US$) in New Zealand in 1996 and the Value added (constant 2005 US$) in Sudan in 1999?
Provide a short and direct response. -3.35e+09. What is the difference between the Value added (constant 2005 US$) in Heavily indebted poor countries in 1997 and the Value added (constant 2005 US$) in Small states in 1998?
Ensure brevity in your answer.  4.73e+1. What is the difference between the Value added (constant 2005 US$) of Heavily indebted poor countries in 1997 and the Value added (constant 2005 US$) of New Zealand in 1998?
Give a very brief answer. 4.84e+1. What is the difference between the Value added (constant 2005 US$) of Heavily indebted poor countries in 1997 and the Value added (constant 2005 US$) of Sudan in 1998?
Keep it short and to the point. 4.49e+1. What is the difference between the Value added (constant 2005 US$) of Small states in 1997 and the Value added (constant 2005 US$) of New Zealand in 1998?
Keep it short and to the point. 1.23e+09. What is the difference between the Value added (constant 2005 US$) in Small states in 1997 and the Value added (constant 2005 US$) in Sudan in 1998?
Provide a short and direct response. -2.27e+09. What is the difference between the Value added (constant 2005 US$) in New Zealand in 1997 and the Value added (constant 2005 US$) in Sudan in 1998?
Ensure brevity in your answer.  -3.31e+09. What is the difference between the Value added (constant 2005 US$) of Heavily indebted poor countries in 1997 and the Value added (constant 2005 US$) of Small states in 1999?
Give a very brief answer. 4.71e+1. What is the difference between the Value added (constant 2005 US$) of Heavily indebted poor countries in 1997 and the Value added (constant 2005 US$) of New Zealand in 1999?
Your answer should be compact. 4.82e+1. What is the difference between the Value added (constant 2005 US$) in Heavily indebted poor countries in 1997 and the Value added (constant 2005 US$) in Sudan in 1999?
Your answer should be very brief. 4.49e+1. What is the difference between the Value added (constant 2005 US$) of Small states in 1997 and the Value added (constant 2005 US$) of New Zealand in 1999?
Give a very brief answer. 1.03e+09. What is the difference between the Value added (constant 2005 US$) in Small states in 1997 and the Value added (constant 2005 US$) in Sudan in 1999?
Provide a succinct answer. -2.30e+09. What is the difference between the Value added (constant 2005 US$) in New Zealand in 1997 and the Value added (constant 2005 US$) in Sudan in 1999?
Your answer should be compact. -3.34e+09. What is the difference between the Value added (constant 2005 US$) in Heavily indebted poor countries in 1998 and the Value added (constant 2005 US$) in Small states in 1999?
Your answer should be very brief. 4.81e+1. What is the difference between the Value added (constant 2005 US$) in Heavily indebted poor countries in 1998 and the Value added (constant 2005 US$) in New Zealand in 1999?
Your answer should be compact. 4.93e+1. What is the difference between the Value added (constant 2005 US$) of Heavily indebted poor countries in 1998 and the Value added (constant 2005 US$) of Sudan in 1999?
Offer a very short reply. 4.60e+1. What is the difference between the Value added (constant 2005 US$) in Small states in 1998 and the Value added (constant 2005 US$) in New Zealand in 1999?
Ensure brevity in your answer.  9.74e+08. What is the difference between the Value added (constant 2005 US$) in Small states in 1998 and the Value added (constant 2005 US$) in Sudan in 1999?
Provide a succinct answer. -2.35e+09. What is the difference between the Value added (constant 2005 US$) in New Zealand in 1998 and the Value added (constant 2005 US$) in Sudan in 1999?
Your answer should be very brief. -3.53e+09. What is the average Value added (constant 2005 US$) of Heavily indebted poor countries per year?
Give a very brief answer. 4.86e+1. What is the average Value added (constant 2005 US$) in Small states per year?
Offer a terse response. 5.48e+09. What is the average Value added (constant 2005 US$) in New Zealand per year?
Make the answer very short. 4.12e+09. What is the average Value added (constant 2005 US$) in Sudan per year?
Your answer should be compact. 6.32e+09. In the year 1992, what is the difference between the Value added (constant 2005 US$) in Heavily indebted poor countries and Value added (constant 2005 US$) in Small states?
Your answer should be compact. 3.64e+1. In the year 1992, what is the difference between the Value added (constant 2005 US$) of Heavily indebted poor countries and Value added (constant 2005 US$) of New Zealand?
Your response must be concise. 3.83e+1. In the year 1992, what is the difference between the Value added (constant 2005 US$) of Heavily indebted poor countries and Value added (constant 2005 US$) of Sudan?
Offer a terse response. 3.64e+1. In the year 1992, what is the difference between the Value added (constant 2005 US$) in Small states and Value added (constant 2005 US$) in New Zealand?
Make the answer very short. 1.91e+09. In the year 1992, what is the difference between the Value added (constant 2005 US$) of Small states and Value added (constant 2005 US$) of Sudan?
Ensure brevity in your answer.  3.58e+06. In the year 1992, what is the difference between the Value added (constant 2005 US$) in New Zealand and Value added (constant 2005 US$) in Sudan?
Your response must be concise. -1.90e+09. In the year 1993, what is the difference between the Value added (constant 2005 US$) in Heavily indebted poor countries and Value added (constant 2005 US$) in Small states?
Your answer should be very brief. 3.90e+1. In the year 1993, what is the difference between the Value added (constant 2005 US$) of Heavily indebted poor countries and Value added (constant 2005 US$) of New Zealand?
Give a very brief answer. 4.04e+1. In the year 1993, what is the difference between the Value added (constant 2005 US$) in Heavily indebted poor countries and Value added (constant 2005 US$) in Sudan?
Keep it short and to the point. 3.89e+1. In the year 1993, what is the difference between the Value added (constant 2005 US$) in Small states and Value added (constant 2005 US$) in New Zealand?
Offer a very short reply. 1.39e+09. In the year 1993, what is the difference between the Value added (constant 2005 US$) in Small states and Value added (constant 2005 US$) in Sudan?
Provide a short and direct response. -4.36e+07. In the year 1993, what is the difference between the Value added (constant 2005 US$) in New Zealand and Value added (constant 2005 US$) in Sudan?
Keep it short and to the point. -1.43e+09. In the year 1994, what is the difference between the Value added (constant 2005 US$) in Heavily indebted poor countries and Value added (constant 2005 US$) in Small states?
Provide a succinct answer. 3.82e+1. In the year 1994, what is the difference between the Value added (constant 2005 US$) in Heavily indebted poor countries and Value added (constant 2005 US$) in New Zealand?
Your answer should be very brief. 3.98e+1. In the year 1994, what is the difference between the Value added (constant 2005 US$) in Heavily indebted poor countries and Value added (constant 2005 US$) in Sudan?
Your answer should be very brief. 3.86e+1. In the year 1994, what is the difference between the Value added (constant 2005 US$) in Small states and Value added (constant 2005 US$) in New Zealand?
Ensure brevity in your answer.  1.56e+09. In the year 1994, what is the difference between the Value added (constant 2005 US$) in Small states and Value added (constant 2005 US$) in Sudan?
Offer a very short reply. 3.37e+08. In the year 1994, what is the difference between the Value added (constant 2005 US$) of New Zealand and Value added (constant 2005 US$) of Sudan?
Offer a terse response. -1.22e+09. In the year 1995, what is the difference between the Value added (constant 2005 US$) in Heavily indebted poor countries and Value added (constant 2005 US$) in Small states?
Ensure brevity in your answer.  4.10e+1. In the year 1995, what is the difference between the Value added (constant 2005 US$) of Heavily indebted poor countries and Value added (constant 2005 US$) of New Zealand?
Provide a succinct answer. 4.24e+1. In the year 1995, what is the difference between the Value added (constant 2005 US$) in Heavily indebted poor countries and Value added (constant 2005 US$) in Sudan?
Ensure brevity in your answer.  4.12e+1. In the year 1995, what is the difference between the Value added (constant 2005 US$) in Small states and Value added (constant 2005 US$) in New Zealand?
Provide a succinct answer. 1.43e+09. In the year 1995, what is the difference between the Value added (constant 2005 US$) of Small states and Value added (constant 2005 US$) of Sudan?
Give a very brief answer. 1.78e+08. In the year 1995, what is the difference between the Value added (constant 2005 US$) in New Zealand and Value added (constant 2005 US$) in Sudan?
Ensure brevity in your answer.  -1.25e+09. In the year 1996, what is the difference between the Value added (constant 2005 US$) of Heavily indebted poor countries and Value added (constant 2005 US$) of Small states?
Make the answer very short. 4.46e+1. In the year 1996, what is the difference between the Value added (constant 2005 US$) of Heavily indebted poor countries and Value added (constant 2005 US$) of New Zealand?
Offer a terse response. 4.59e+1. In the year 1996, what is the difference between the Value added (constant 2005 US$) in Heavily indebted poor countries and Value added (constant 2005 US$) in Sudan?
Provide a short and direct response. 4.40e+1. In the year 1996, what is the difference between the Value added (constant 2005 US$) in Small states and Value added (constant 2005 US$) in New Zealand?
Your answer should be compact. 1.26e+09. In the year 1996, what is the difference between the Value added (constant 2005 US$) in Small states and Value added (constant 2005 US$) in Sudan?
Give a very brief answer. -6.49e+08. In the year 1996, what is the difference between the Value added (constant 2005 US$) of New Zealand and Value added (constant 2005 US$) of Sudan?
Your answer should be very brief. -1.91e+09. In the year 1997, what is the difference between the Value added (constant 2005 US$) in Heavily indebted poor countries and Value added (constant 2005 US$) in Small states?
Your answer should be very brief. 4.72e+1. In the year 1997, what is the difference between the Value added (constant 2005 US$) of Heavily indebted poor countries and Value added (constant 2005 US$) of New Zealand?
Ensure brevity in your answer.  4.82e+1. In the year 1997, what is the difference between the Value added (constant 2005 US$) of Heavily indebted poor countries and Value added (constant 2005 US$) of Sudan?
Your answer should be compact. 4.52e+1. In the year 1997, what is the difference between the Value added (constant 2005 US$) of Small states and Value added (constant 2005 US$) of New Zealand?
Provide a short and direct response. 1.04e+09. In the year 1997, what is the difference between the Value added (constant 2005 US$) of Small states and Value added (constant 2005 US$) of Sudan?
Provide a succinct answer. -2.02e+09. In the year 1997, what is the difference between the Value added (constant 2005 US$) of New Zealand and Value added (constant 2005 US$) of Sudan?
Your answer should be compact. -3.06e+09. In the year 1998, what is the difference between the Value added (constant 2005 US$) of Heavily indebted poor countries and Value added (constant 2005 US$) of Small states?
Your answer should be very brief. 4.83e+1. In the year 1998, what is the difference between the Value added (constant 2005 US$) in Heavily indebted poor countries and Value added (constant 2005 US$) in New Zealand?
Your answer should be very brief. 4.95e+1. In the year 1998, what is the difference between the Value added (constant 2005 US$) of Heavily indebted poor countries and Value added (constant 2005 US$) of Sudan?
Offer a terse response. 4.60e+1. In the year 1998, what is the difference between the Value added (constant 2005 US$) in Small states and Value added (constant 2005 US$) in New Zealand?
Offer a very short reply. 1.18e+09. In the year 1998, what is the difference between the Value added (constant 2005 US$) of Small states and Value added (constant 2005 US$) of Sudan?
Ensure brevity in your answer.  -2.33e+09. In the year 1998, what is the difference between the Value added (constant 2005 US$) of New Zealand and Value added (constant 2005 US$) of Sudan?
Give a very brief answer. -3.51e+09. In the year 1999, what is the difference between the Value added (constant 2005 US$) in Heavily indebted poor countries and Value added (constant 2005 US$) in Small states?
Keep it short and to the point. 5.01e+1. In the year 1999, what is the difference between the Value added (constant 2005 US$) in Heavily indebted poor countries and Value added (constant 2005 US$) in New Zealand?
Ensure brevity in your answer.  5.13e+1. In the year 1999, what is the difference between the Value added (constant 2005 US$) in Heavily indebted poor countries and Value added (constant 2005 US$) in Sudan?
Ensure brevity in your answer.  4.79e+1. In the year 1999, what is the difference between the Value added (constant 2005 US$) of Small states and Value added (constant 2005 US$) of New Zealand?
Offer a terse response. 1.15e+09. In the year 1999, what is the difference between the Value added (constant 2005 US$) of Small states and Value added (constant 2005 US$) of Sudan?
Offer a terse response. -2.18e+09. In the year 1999, what is the difference between the Value added (constant 2005 US$) in New Zealand and Value added (constant 2005 US$) in Sudan?
Give a very brief answer. -3.33e+09. What is the ratio of the Value added (constant 2005 US$) in Small states in 1992 to that in 1993?
Keep it short and to the point. 0.99. What is the ratio of the Value added (constant 2005 US$) of New Zealand in 1992 to that in 1993?
Keep it short and to the point. 0.85. What is the ratio of the Value added (constant 2005 US$) of Sudan in 1992 to that in 1993?
Your answer should be compact. 0.98. What is the ratio of the Value added (constant 2005 US$) in Heavily indebted poor countries in 1992 to that in 1994?
Ensure brevity in your answer.  0.95. What is the ratio of the Value added (constant 2005 US$) of Small states in 1992 to that in 1994?
Your answer should be very brief. 0.96. What is the ratio of the Value added (constant 2005 US$) of New Zealand in 1992 to that in 1994?
Your answer should be compact. 0.85. What is the ratio of the Value added (constant 2005 US$) in Sudan in 1992 to that in 1994?
Provide a succinct answer. 1.02. What is the ratio of the Value added (constant 2005 US$) in Heavily indebted poor countries in 1992 to that in 1995?
Ensure brevity in your answer.  0.89. What is the ratio of the Value added (constant 2005 US$) in Small states in 1992 to that in 1995?
Your response must be concise. 0.93. What is the ratio of the Value added (constant 2005 US$) in New Zealand in 1992 to that in 1995?
Ensure brevity in your answer.  0.8. What is the ratio of the Value added (constant 2005 US$) in Sudan in 1992 to that in 1995?
Your answer should be very brief. 0.96. What is the ratio of the Value added (constant 2005 US$) of Heavily indebted poor countries in 1992 to that in 1996?
Give a very brief answer. 0.82. What is the ratio of the Value added (constant 2005 US$) of Small states in 1992 to that in 1996?
Make the answer very short. 0.9. What is the ratio of the Value added (constant 2005 US$) of New Zealand in 1992 to that in 1996?
Provide a succinct answer. 0.73. What is the ratio of the Value added (constant 2005 US$) of Sudan in 1992 to that in 1996?
Make the answer very short. 0.81. What is the ratio of the Value added (constant 2005 US$) in Heavily indebted poor countries in 1992 to that in 1997?
Your answer should be very brief. 0.79. What is the ratio of the Value added (constant 2005 US$) of Small states in 1992 to that in 1997?
Your answer should be very brief. 0.94. What is the ratio of the Value added (constant 2005 US$) of New Zealand in 1992 to that in 1997?
Make the answer very short. 0.73. What is the ratio of the Value added (constant 2005 US$) in Sudan in 1992 to that in 1997?
Your response must be concise. 0.69. What is the ratio of the Value added (constant 2005 US$) of Heavily indebted poor countries in 1992 to that in 1998?
Offer a terse response. 0.77. What is the ratio of the Value added (constant 2005 US$) in Small states in 1992 to that in 1998?
Offer a terse response. 0.94. What is the ratio of the Value added (constant 2005 US$) of New Zealand in 1992 to that in 1998?
Your answer should be compact. 0.76. What is the ratio of the Value added (constant 2005 US$) of Sudan in 1992 to that in 1998?
Keep it short and to the point. 0.66. What is the ratio of the Value added (constant 2005 US$) in Heavily indebted poor countries in 1992 to that in 1999?
Make the answer very short. 0.74. What is the ratio of the Value added (constant 2005 US$) of Small states in 1992 to that in 1999?
Provide a short and direct response. 0.92. What is the ratio of the Value added (constant 2005 US$) in New Zealand in 1992 to that in 1999?
Make the answer very short. 0.73. What is the ratio of the Value added (constant 2005 US$) of Sudan in 1992 to that in 1999?
Provide a short and direct response. 0.66. What is the ratio of the Value added (constant 2005 US$) of Heavily indebted poor countries in 1993 to that in 1994?
Your answer should be compact. 1.01. What is the ratio of the Value added (constant 2005 US$) in Small states in 1993 to that in 1994?
Provide a short and direct response. 0.97. What is the ratio of the Value added (constant 2005 US$) of Sudan in 1993 to that in 1994?
Your answer should be very brief. 1.04. What is the ratio of the Value added (constant 2005 US$) of Heavily indebted poor countries in 1993 to that in 1995?
Your answer should be compact. 0.95. What is the ratio of the Value added (constant 2005 US$) of Small states in 1993 to that in 1995?
Your answer should be very brief. 0.94. What is the ratio of the Value added (constant 2005 US$) of New Zealand in 1993 to that in 1995?
Give a very brief answer. 0.93. What is the ratio of the Value added (constant 2005 US$) in Sudan in 1993 to that in 1995?
Ensure brevity in your answer.  0.98. What is the ratio of the Value added (constant 2005 US$) in Heavily indebted poor countries in 1993 to that in 1996?
Keep it short and to the point. 0.88. What is the ratio of the Value added (constant 2005 US$) of Small states in 1993 to that in 1996?
Keep it short and to the point. 0.91. What is the ratio of the Value added (constant 2005 US$) of New Zealand in 1993 to that in 1996?
Keep it short and to the point. 0.86. What is the ratio of the Value added (constant 2005 US$) in Sudan in 1993 to that in 1996?
Give a very brief answer. 0.82. What is the ratio of the Value added (constant 2005 US$) in Heavily indebted poor countries in 1993 to that in 1997?
Ensure brevity in your answer.  0.84. What is the ratio of the Value added (constant 2005 US$) in Small states in 1993 to that in 1997?
Ensure brevity in your answer.  0.94. What is the ratio of the Value added (constant 2005 US$) of New Zealand in 1993 to that in 1997?
Keep it short and to the point. 0.85. What is the ratio of the Value added (constant 2005 US$) of Sudan in 1993 to that in 1997?
Your response must be concise. 0.7. What is the ratio of the Value added (constant 2005 US$) in Heavily indebted poor countries in 1993 to that in 1998?
Give a very brief answer. 0.82. What is the ratio of the Value added (constant 2005 US$) in Small states in 1993 to that in 1998?
Provide a succinct answer. 0.95. What is the ratio of the Value added (constant 2005 US$) of New Zealand in 1993 to that in 1998?
Keep it short and to the point. 0.89. What is the ratio of the Value added (constant 2005 US$) of Sudan in 1993 to that in 1998?
Make the answer very short. 0.67. What is the ratio of the Value added (constant 2005 US$) of Heavily indebted poor countries in 1993 to that in 1999?
Keep it short and to the point. 0.79. What is the ratio of the Value added (constant 2005 US$) of Small states in 1993 to that in 1999?
Make the answer very short. 0.92. What is the ratio of the Value added (constant 2005 US$) of New Zealand in 1993 to that in 1999?
Make the answer very short. 0.85. What is the ratio of the Value added (constant 2005 US$) of Sudan in 1993 to that in 1999?
Your answer should be compact. 0.67. What is the ratio of the Value added (constant 2005 US$) of Heavily indebted poor countries in 1994 to that in 1995?
Ensure brevity in your answer.  0.94. What is the ratio of the Value added (constant 2005 US$) in Small states in 1994 to that in 1995?
Your response must be concise. 0.97. What is the ratio of the Value added (constant 2005 US$) of New Zealand in 1994 to that in 1995?
Keep it short and to the point. 0.93. What is the ratio of the Value added (constant 2005 US$) in Sudan in 1994 to that in 1995?
Provide a short and direct response. 0.94. What is the ratio of the Value added (constant 2005 US$) of Heavily indebted poor countries in 1994 to that in 1996?
Your response must be concise. 0.87. What is the ratio of the Value added (constant 2005 US$) in Small states in 1994 to that in 1996?
Ensure brevity in your answer.  0.94. What is the ratio of the Value added (constant 2005 US$) of New Zealand in 1994 to that in 1996?
Make the answer very short. 0.86. What is the ratio of the Value added (constant 2005 US$) in Sudan in 1994 to that in 1996?
Provide a succinct answer. 0.79. What is the ratio of the Value added (constant 2005 US$) in Heavily indebted poor countries in 1994 to that in 1997?
Provide a succinct answer. 0.83. What is the ratio of the Value added (constant 2005 US$) of Small states in 1994 to that in 1997?
Keep it short and to the point. 0.98. What is the ratio of the Value added (constant 2005 US$) in New Zealand in 1994 to that in 1997?
Make the answer very short. 0.85. What is the ratio of the Value added (constant 2005 US$) in Sudan in 1994 to that in 1997?
Provide a short and direct response. 0.67. What is the ratio of the Value added (constant 2005 US$) of Heavily indebted poor countries in 1994 to that in 1998?
Provide a succinct answer. 0.81. What is the ratio of the Value added (constant 2005 US$) in Small states in 1994 to that in 1998?
Provide a succinct answer. 0.99. What is the ratio of the Value added (constant 2005 US$) in New Zealand in 1994 to that in 1998?
Your response must be concise. 0.89. What is the ratio of the Value added (constant 2005 US$) of Sudan in 1994 to that in 1998?
Give a very brief answer. 0.65. What is the ratio of the Value added (constant 2005 US$) of Heavily indebted poor countries in 1994 to that in 1999?
Your answer should be very brief. 0.78. What is the ratio of the Value added (constant 2005 US$) in Small states in 1994 to that in 1999?
Offer a terse response. 0.95. What is the ratio of the Value added (constant 2005 US$) in New Zealand in 1994 to that in 1999?
Your answer should be very brief. 0.85. What is the ratio of the Value added (constant 2005 US$) in Sudan in 1994 to that in 1999?
Keep it short and to the point. 0.65. What is the ratio of the Value added (constant 2005 US$) in Heavily indebted poor countries in 1995 to that in 1996?
Your response must be concise. 0.92. What is the ratio of the Value added (constant 2005 US$) in Small states in 1995 to that in 1996?
Make the answer very short. 0.97. What is the ratio of the Value added (constant 2005 US$) in New Zealand in 1995 to that in 1996?
Keep it short and to the point. 0.92. What is the ratio of the Value added (constant 2005 US$) of Sudan in 1995 to that in 1996?
Offer a terse response. 0.84. What is the ratio of the Value added (constant 2005 US$) of Heavily indebted poor countries in 1995 to that in 1997?
Offer a very short reply. 0.88. What is the ratio of the Value added (constant 2005 US$) in New Zealand in 1995 to that in 1997?
Provide a succinct answer. 0.92. What is the ratio of the Value added (constant 2005 US$) in Sudan in 1995 to that in 1997?
Keep it short and to the point. 0.71. What is the ratio of the Value added (constant 2005 US$) of Heavily indebted poor countries in 1995 to that in 1998?
Offer a very short reply. 0.87. What is the ratio of the Value added (constant 2005 US$) of Small states in 1995 to that in 1998?
Offer a very short reply. 1.01. What is the ratio of the Value added (constant 2005 US$) in Sudan in 1995 to that in 1998?
Your response must be concise. 0.69. What is the ratio of the Value added (constant 2005 US$) in Heavily indebted poor countries in 1995 to that in 1999?
Your answer should be very brief. 0.83. What is the ratio of the Value added (constant 2005 US$) of Small states in 1995 to that in 1999?
Give a very brief answer. 0.98. What is the ratio of the Value added (constant 2005 US$) of New Zealand in 1995 to that in 1999?
Provide a short and direct response. 0.91. What is the ratio of the Value added (constant 2005 US$) of Sudan in 1995 to that in 1999?
Your response must be concise. 0.69. What is the ratio of the Value added (constant 2005 US$) of Heavily indebted poor countries in 1996 to that in 1997?
Your answer should be compact. 0.95. What is the ratio of the Value added (constant 2005 US$) in Sudan in 1996 to that in 1997?
Offer a very short reply. 0.85. What is the ratio of the Value added (constant 2005 US$) in Heavily indebted poor countries in 1996 to that in 1998?
Make the answer very short. 0.94. What is the ratio of the Value added (constant 2005 US$) in Small states in 1996 to that in 1998?
Your answer should be very brief. 1.05. What is the ratio of the Value added (constant 2005 US$) of New Zealand in 1996 to that in 1998?
Your response must be concise. 1.04. What is the ratio of the Value added (constant 2005 US$) of Sudan in 1996 to that in 1998?
Provide a short and direct response. 0.82. What is the ratio of the Value added (constant 2005 US$) in Heavily indebted poor countries in 1996 to that in 1999?
Make the answer very short. 0.9. What is the ratio of the Value added (constant 2005 US$) in Small states in 1996 to that in 1999?
Keep it short and to the point. 1.01. What is the ratio of the Value added (constant 2005 US$) in New Zealand in 1996 to that in 1999?
Offer a very short reply. 0.99. What is the ratio of the Value added (constant 2005 US$) of Sudan in 1996 to that in 1999?
Your response must be concise. 0.82. What is the ratio of the Value added (constant 2005 US$) in Heavily indebted poor countries in 1997 to that in 1998?
Your answer should be very brief. 0.98. What is the ratio of the Value added (constant 2005 US$) in Small states in 1997 to that in 1998?
Keep it short and to the point. 1.01. What is the ratio of the Value added (constant 2005 US$) in New Zealand in 1997 to that in 1998?
Ensure brevity in your answer.  1.05. What is the ratio of the Value added (constant 2005 US$) of Sudan in 1997 to that in 1998?
Provide a short and direct response. 0.97. What is the ratio of the Value added (constant 2005 US$) in Heavily indebted poor countries in 1997 to that in 1999?
Provide a short and direct response. 0.95. What is the ratio of the Value added (constant 2005 US$) of Small states in 1997 to that in 1999?
Make the answer very short. 0.98. What is the ratio of the Value added (constant 2005 US$) in Sudan in 1997 to that in 1999?
Your answer should be compact. 0.96. What is the ratio of the Value added (constant 2005 US$) of Heavily indebted poor countries in 1998 to that in 1999?
Ensure brevity in your answer.  0.96. What is the ratio of the Value added (constant 2005 US$) of New Zealand in 1998 to that in 1999?
Offer a very short reply. 0.95. What is the ratio of the Value added (constant 2005 US$) in Sudan in 1998 to that in 1999?
Make the answer very short. 1. What is the difference between the highest and the second highest Value added (constant 2005 US$) of Heavily indebted poor countries?
Make the answer very short. 2.00e+09. What is the difference between the highest and the second highest Value added (constant 2005 US$) of Small states?
Your response must be concise. 8.41e+07. What is the difference between the highest and the second highest Value added (constant 2005 US$) of New Zealand?
Your response must be concise. 1.00e+07. What is the difference between the highest and the second highest Value added (constant 2005 US$) in Sudan?
Provide a short and direct response. 2.61e+07. What is the difference between the highest and the lowest Value added (constant 2005 US$) in Heavily indebted poor countries?
Your answer should be very brief. 1.42e+1. What is the difference between the highest and the lowest Value added (constant 2005 US$) of Small states?
Your answer should be very brief. 5.63e+08. What is the difference between the highest and the lowest Value added (constant 2005 US$) of New Zealand?
Provide a succinct answer. 1.23e+09. What is the difference between the highest and the lowest Value added (constant 2005 US$) of Sudan?
Offer a very short reply. 2.77e+09. 